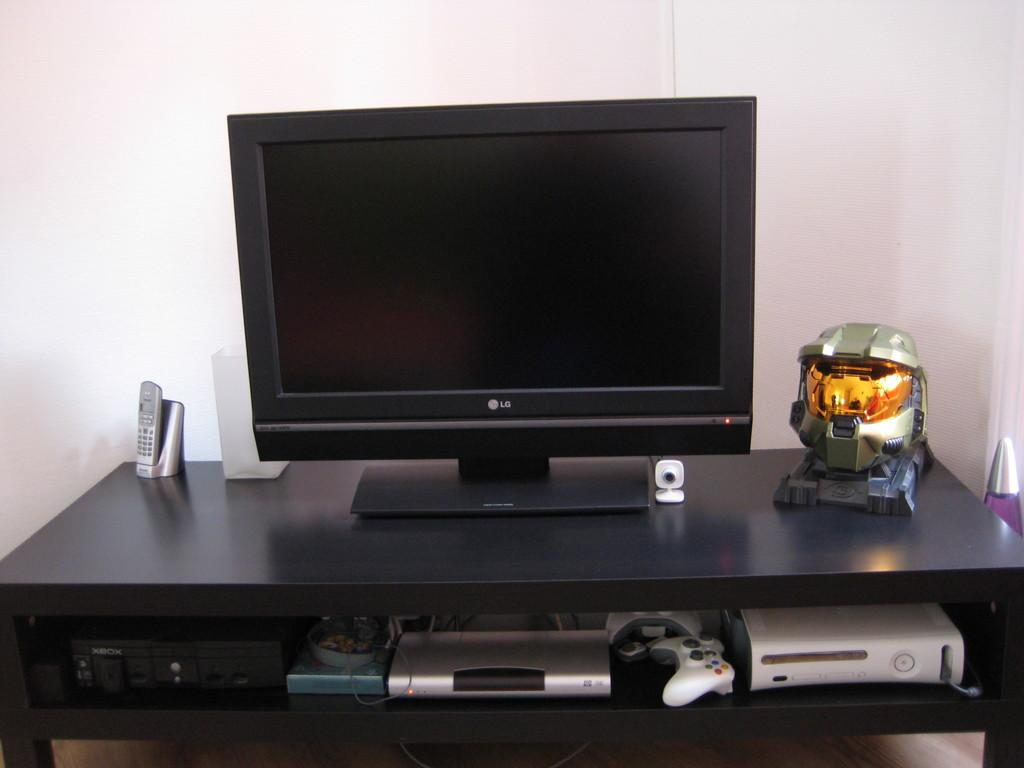What electronic device is visible in the image? There is a TV in the image. What can be seen on a piece of furniture in the image? There are objects on a table in the image. What is located beside the table in the image? There is an object beside the table in the image. What is visible in the background of the image? There is a wall in the background of the image. What type of shirt is the authority wearing in the image? There is no authority figure or shirt present in the image. How many times does the person kick the object in the image? There are no people or objects being kicked in the image. 